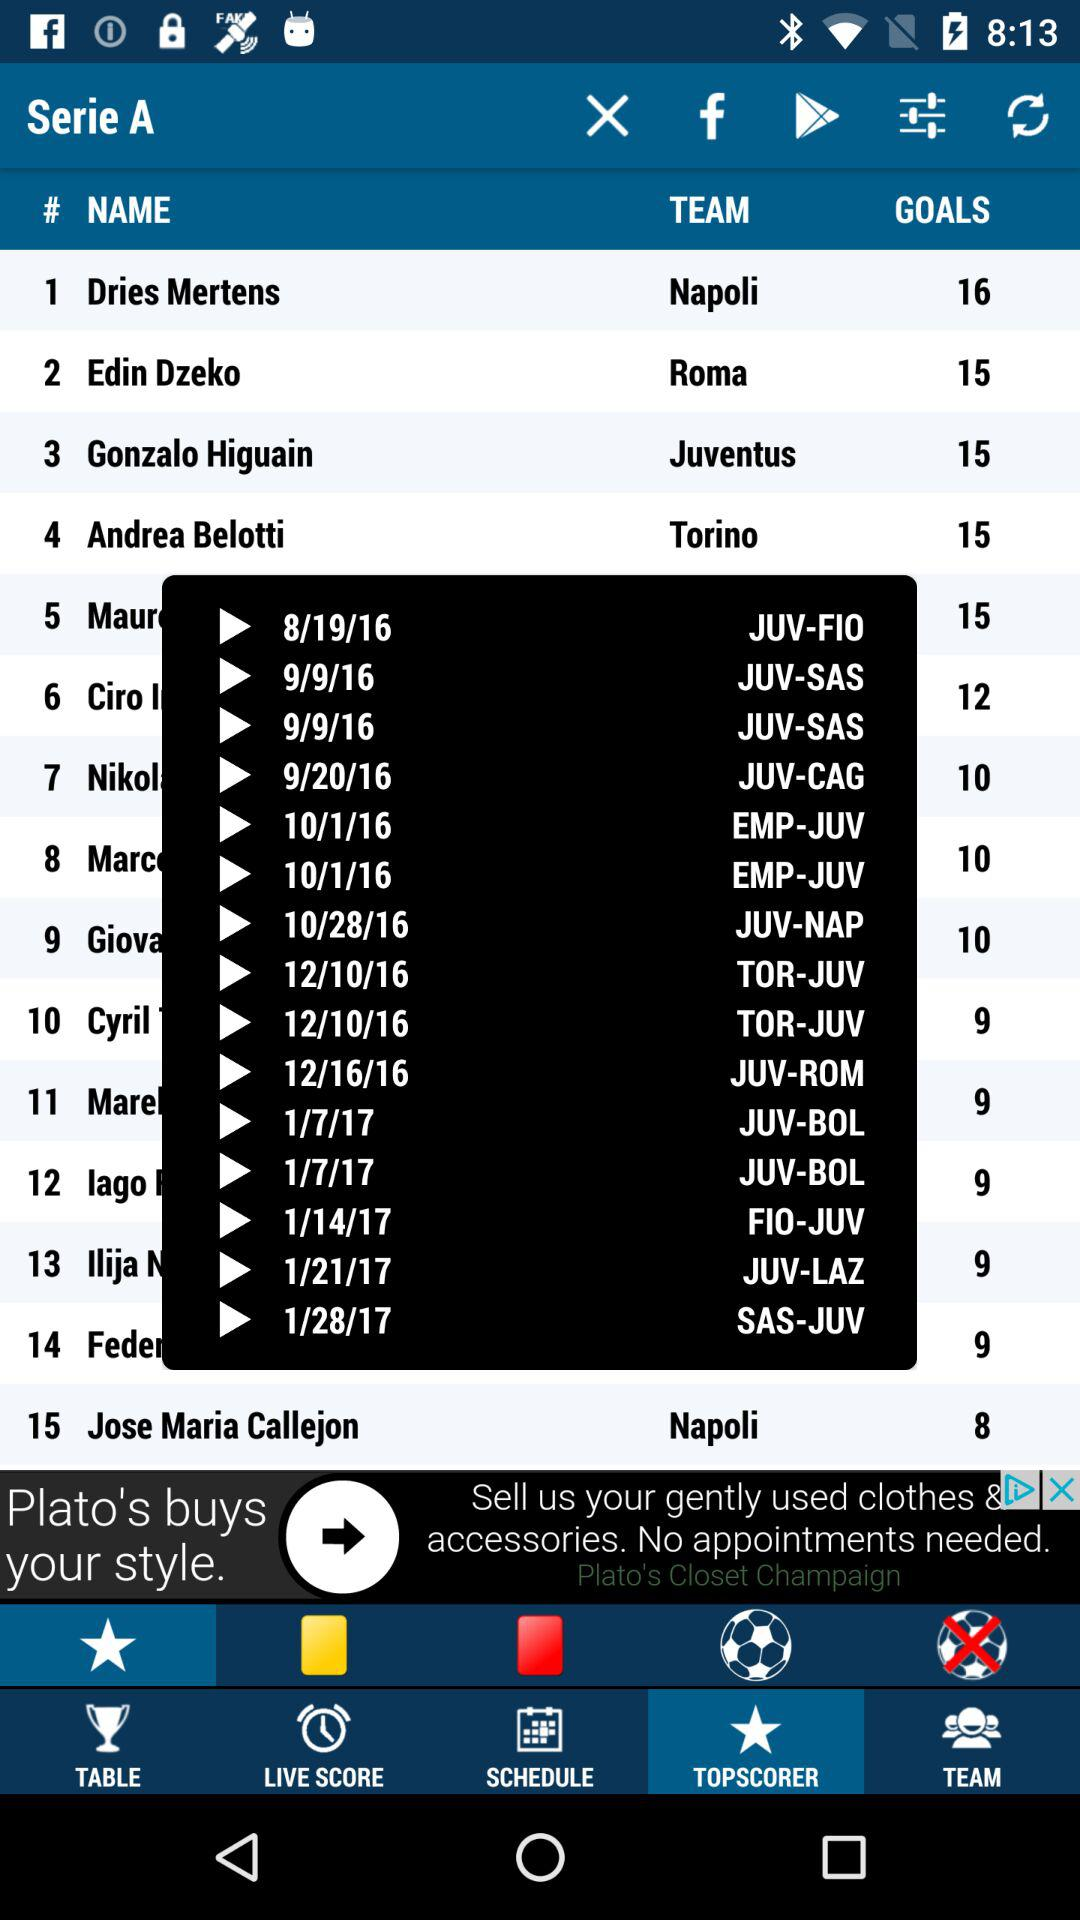How many more goals has Dries Mertens scored than Gonzalo Higuain?
Answer the question using a single word or phrase. 1 